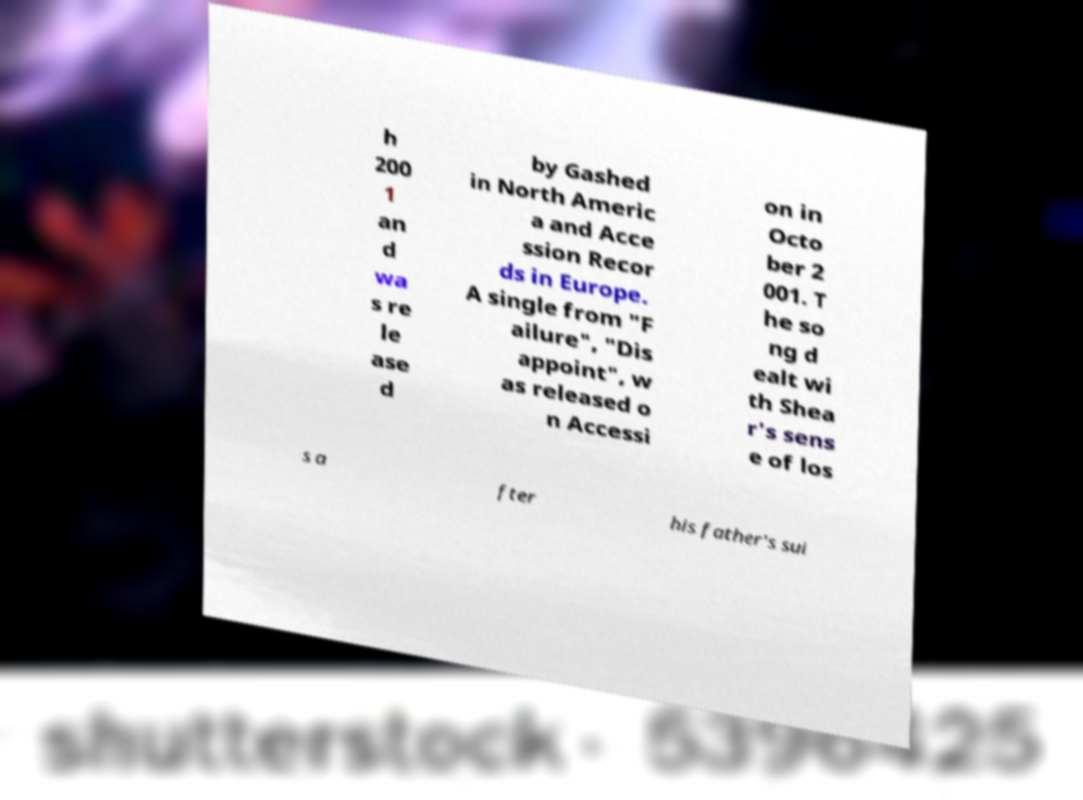For documentation purposes, I need the text within this image transcribed. Could you provide that? h 200 1 an d wa s re le ase d by Gashed in North Americ a and Acce ssion Recor ds in Europe. A single from "F ailure", "Dis appoint", w as released o n Accessi on in Octo ber 2 001. T he so ng d ealt wi th Shea r's sens e of los s a fter his father's sui 